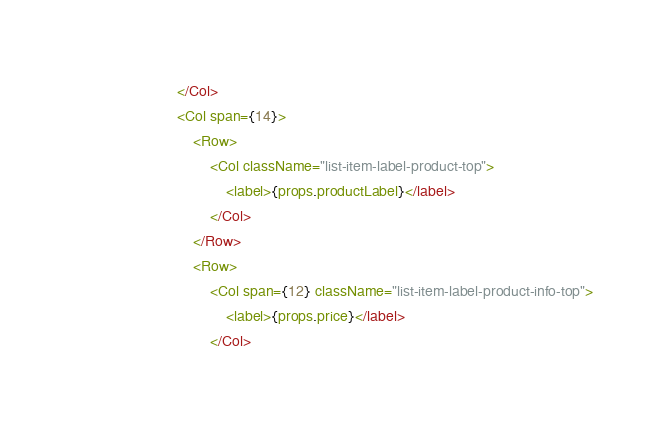<code> <loc_0><loc_0><loc_500><loc_500><_JavaScript_>						</Col>
						<Col span={14}>
							<Row>
								<Col className="list-item-label-product-top">
									<label>{props.productLabel}</label>
								</Col>
							</Row>
							<Row>
								<Col span={12} className="list-item-label-product-info-top">
									<label>{props.price}</label>
								</Col></code> 